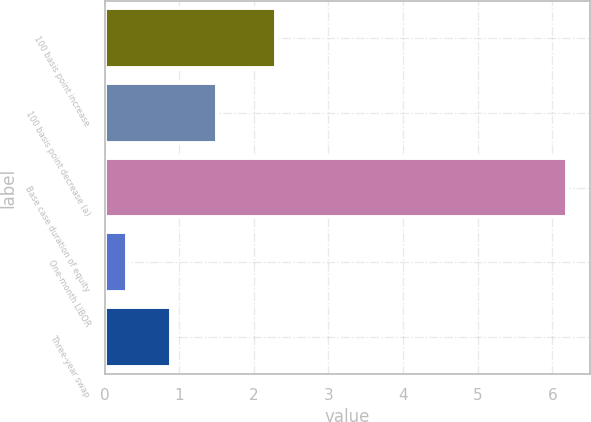Convert chart. <chart><loc_0><loc_0><loc_500><loc_500><bar_chart><fcel>100 basis point increase<fcel>100 basis point decrease (a)<fcel>Base case duration of equity<fcel>One-month LIBOR<fcel>Three-year swap<nl><fcel>2.3<fcel>1.5<fcel>6.2<fcel>0.3<fcel>0.89<nl></chart> 